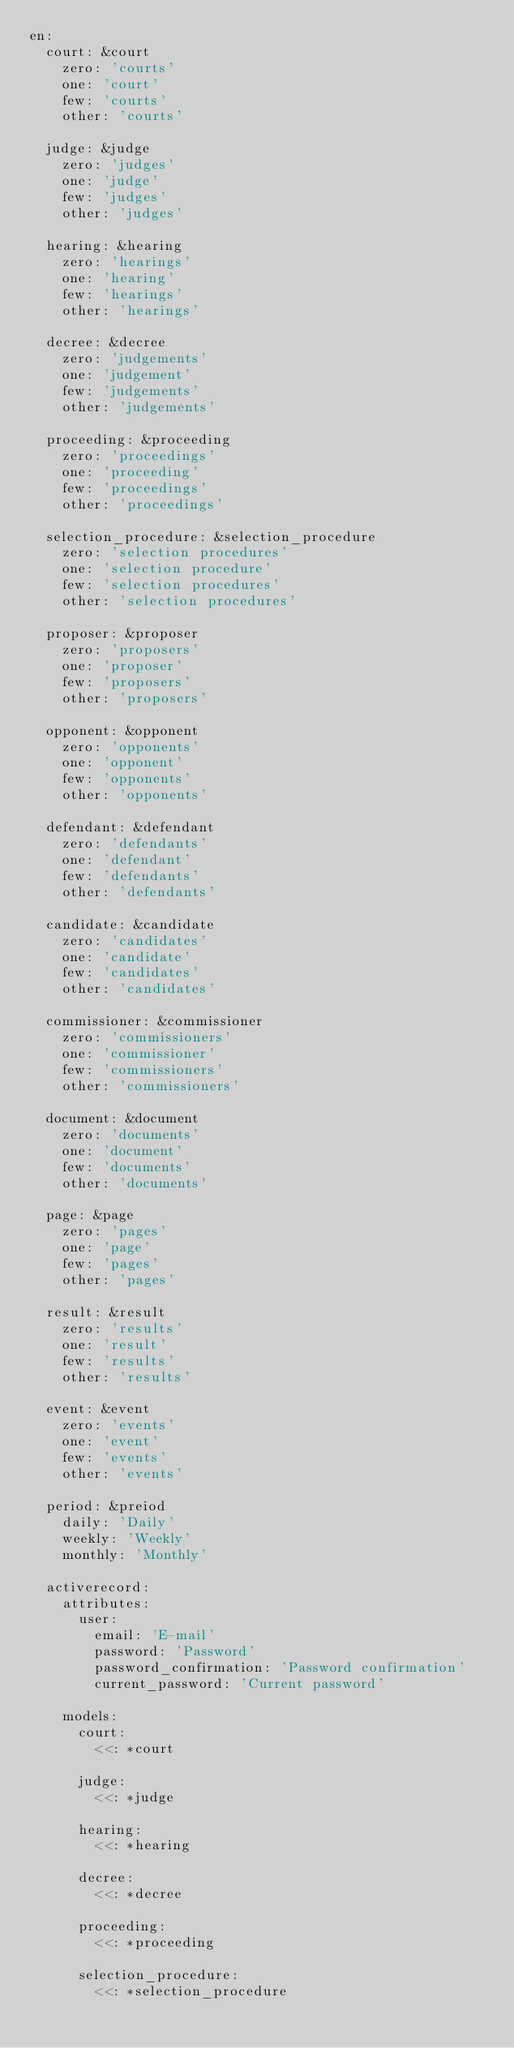<code> <loc_0><loc_0><loc_500><loc_500><_YAML_>en:
  court: &court
    zero: 'courts'
    one: 'court'
    few: 'courts'
    other: 'courts'

  judge: &judge
    zero: 'judges'
    one: 'judge'
    few: 'judges'
    other: 'judges'

  hearing: &hearing
    zero: 'hearings'
    one: 'hearing'
    few: 'hearings'
    other: 'hearings'

  decree: &decree
    zero: 'judgements'
    one: 'judgement'
    few: 'judgements'
    other: 'judgements'

  proceeding: &proceeding
    zero: 'proceedings'
    one: 'proceeding'
    few: 'proceedings'
    other: 'proceedings'

  selection_procedure: &selection_procedure
    zero: 'selection procedures'
    one: 'selection procedure'
    few: 'selection procedures'
    other: 'selection procedures'

  proposer: &proposer
    zero: 'proposers'
    one: 'proposer'
    few: 'proposers'
    other: 'proposers'

  opponent: &opponent
    zero: 'opponents'
    one: 'opponent'
    few: 'opponents'
    other: 'opponents'

  defendant: &defendant
    zero: 'defendants'
    one: 'defendant'
    few: 'defendants'
    other: 'defendants'

  candidate: &candidate
    zero: 'candidates'
    one: 'candidate'
    few: 'candidates'
    other: 'candidates'

  commissioner: &commissioner
    zero: 'commissioners'
    one: 'commissioner'
    few: 'commissioners'
    other: 'commissioners'

  document: &document
    zero: 'documents'
    one: 'document'
    few: 'documents'
    other: 'documents'

  page: &page
    zero: 'pages'
    one: 'page'
    few: 'pages'
    other: 'pages'

  result: &result
    zero: 'results'
    one: 'result'
    few: 'results'
    other: 'results'

  event: &event
    zero: 'events'
    one: 'event'
    few: 'events'
    other: 'events'

  period: &preiod
    daily: 'Daily'
    weekly: 'Weekly'
    monthly: 'Monthly'

  activerecord:
    attributes:
      user:
        email: 'E-mail'
        password: 'Password'
        password_confirmation: 'Password confirmation'
        current_password: 'Current password'

    models:
      court:
        <<: *court

      judge:
        <<: *judge

      hearing:
        <<: *hearing

      decree:
        <<: *decree

      proceeding:
        <<: *proceeding

      selection_procedure:
        <<: *selection_procedure
</code> 